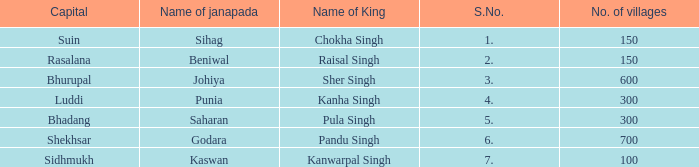What is the highest S number with a capital of Shekhsar? 6.0. 